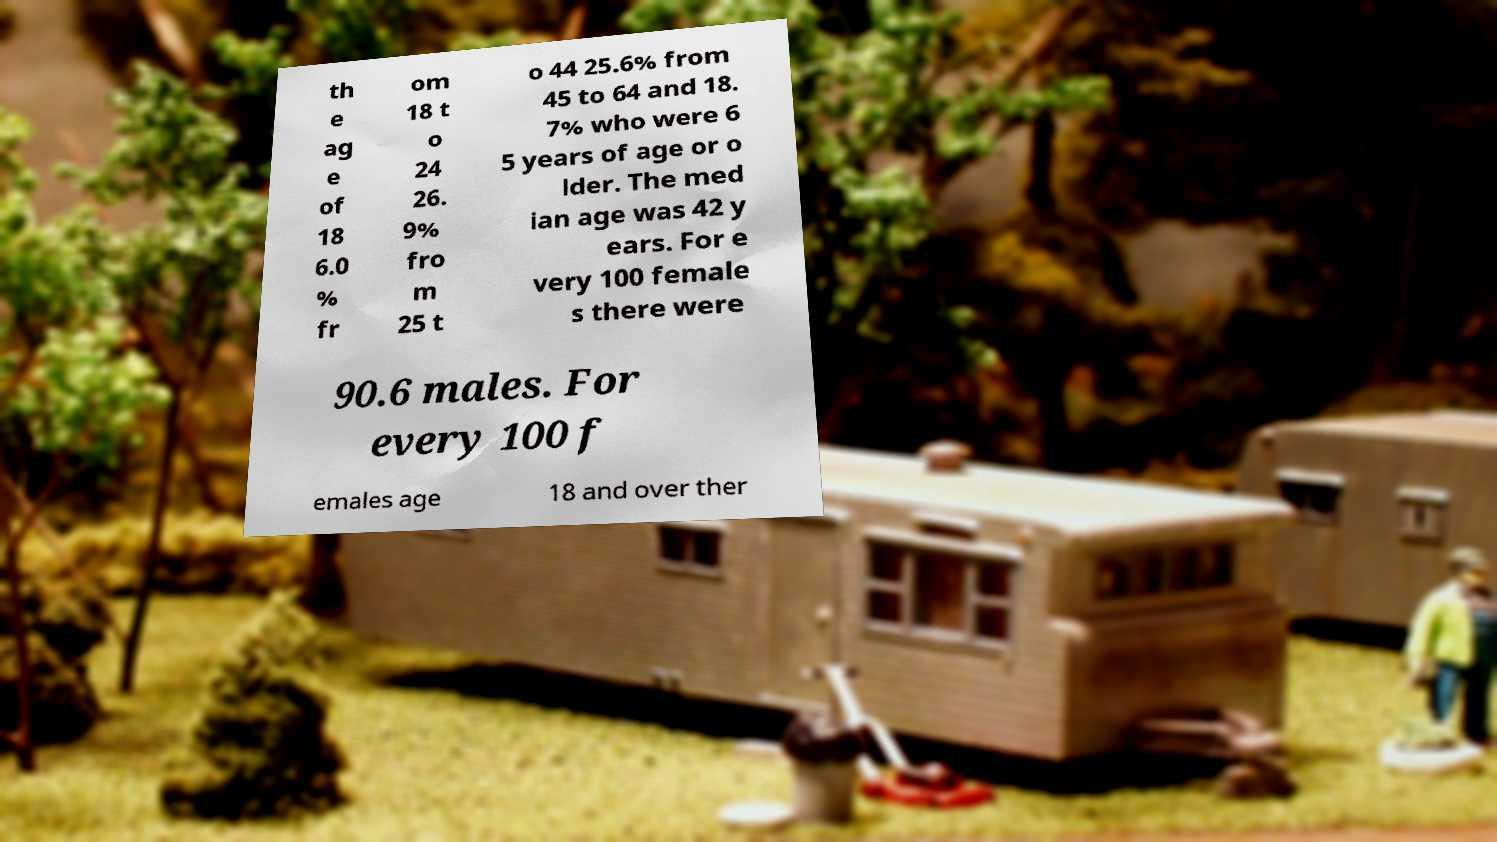Please read and relay the text visible in this image. What does it say? th e ag e of 18 6.0 % fr om 18 t o 24 26. 9% fro m 25 t o 44 25.6% from 45 to 64 and 18. 7% who were 6 5 years of age or o lder. The med ian age was 42 y ears. For e very 100 female s there were 90.6 males. For every 100 f emales age 18 and over ther 